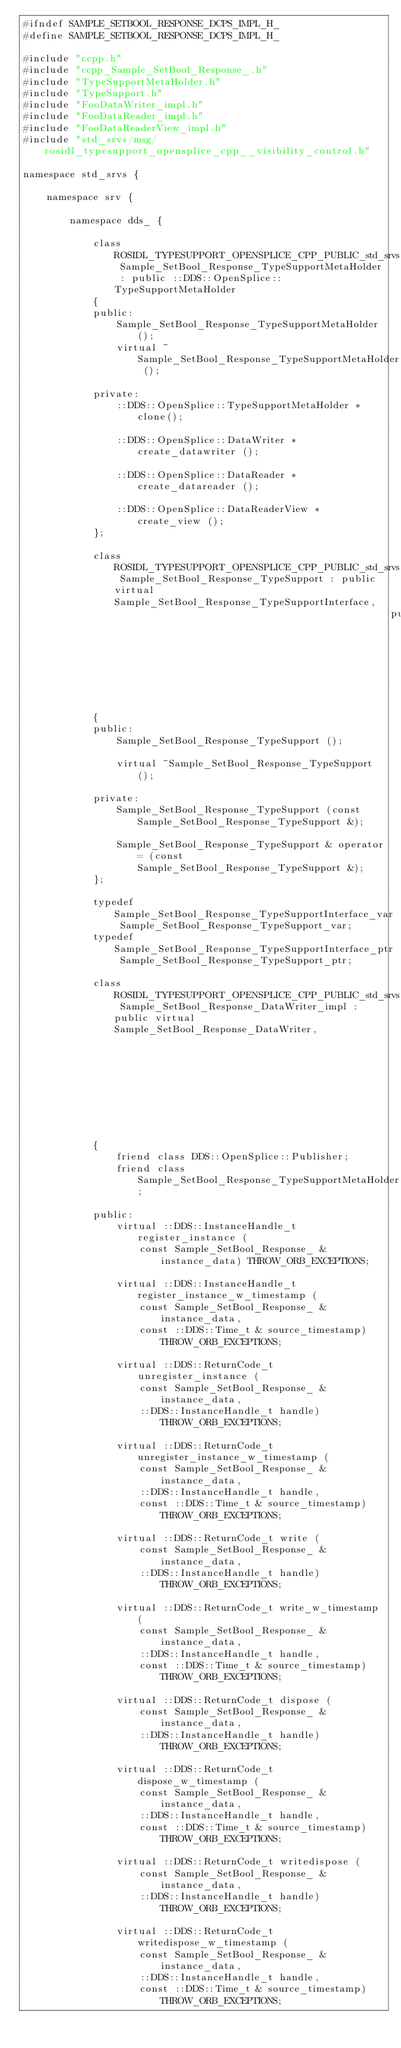Convert code to text. <code><loc_0><loc_0><loc_500><loc_500><_C_>#ifndef SAMPLE_SETBOOL_RESPONSE_DCPS_IMPL_H_
#define SAMPLE_SETBOOL_RESPONSE_DCPS_IMPL_H_

#include "ccpp.h"
#include "ccpp_Sample_SetBool_Response_.h"
#include "TypeSupportMetaHolder.h"
#include "TypeSupport.h"
#include "FooDataWriter_impl.h"
#include "FooDataReader_impl.h"
#include "FooDataReaderView_impl.h"
#include "std_srvs/msg/rosidl_typesupport_opensplice_cpp__visibility_control.h"

namespace std_srvs {

    namespace srv {

        namespace dds_ {

            class ROSIDL_TYPESUPPORT_OPENSPLICE_CPP_PUBLIC_std_srvs Sample_SetBool_Response_TypeSupportMetaHolder : public ::DDS::OpenSplice::TypeSupportMetaHolder
            {
            public:
                Sample_SetBool_Response_TypeSupportMetaHolder ();
                virtual ~Sample_SetBool_Response_TypeSupportMetaHolder ();
            
            private:
                ::DDS::OpenSplice::TypeSupportMetaHolder * clone();
            
                ::DDS::OpenSplice::DataWriter * create_datawriter ();
            
                ::DDS::OpenSplice::DataReader * create_datareader ();
            
                ::DDS::OpenSplice::DataReaderView * create_view ();
            };
            
            class ROSIDL_TYPESUPPORT_OPENSPLICE_CPP_PUBLIC_std_srvs Sample_SetBool_Response_TypeSupport : public virtual Sample_SetBool_Response_TypeSupportInterface,
                                                               public ::DDS::OpenSplice::TypeSupport
            {
            public:
                Sample_SetBool_Response_TypeSupport ();
            
                virtual ~Sample_SetBool_Response_TypeSupport ();
            
            private:
                Sample_SetBool_Response_TypeSupport (const Sample_SetBool_Response_TypeSupport &);
            
                Sample_SetBool_Response_TypeSupport & operator= (const Sample_SetBool_Response_TypeSupport &);
            };
            
            typedef Sample_SetBool_Response_TypeSupportInterface_var Sample_SetBool_Response_TypeSupport_var;
            typedef Sample_SetBool_Response_TypeSupportInterface_ptr Sample_SetBool_Response_TypeSupport_ptr;
            
            class ROSIDL_TYPESUPPORT_OPENSPLICE_CPP_PUBLIC_std_srvs Sample_SetBool_Response_DataWriter_impl : public virtual Sample_SetBool_Response_DataWriter,
                                                                   public ::DDS::OpenSplice::FooDataWriter_impl
            {
                friend class DDS::OpenSplice::Publisher;
                friend class Sample_SetBool_Response_TypeSupportMetaHolder;
            
            public:
                virtual ::DDS::InstanceHandle_t register_instance (
                    const Sample_SetBool_Response_ & instance_data) THROW_ORB_EXCEPTIONS;
            
                virtual ::DDS::InstanceHandle_t register_instance_w_timestamp (
                    const Sample_SetBool_Response_ & instance_data,
                    const ::DDS::Time_t & source_timestamp) THROW_ORB_EXCEPTIONS;
            
                virtual ::DDS::ReturnCode_t unregister_instance (
                    const Sample_SetBool_Response_ & instance_data,
                    ::DDS::InstanceHandle_t handle) THROW_ORB_EXCEPTIONS;
            
                virtual ::DDS::ReturnCode_t unregister_instance_w_timestamp (
                    const Sample_SetBool_Response_ & instance_data,
                    ::DDS::InstanceHandle_t handle,
                    const ::DDS::Time_t & source_timestamp) THROW_ORB_EXCEPTIONS;
            
                virtual ::DDS::ReturnCode_t write (
                    const Sample_SetBool_Response_ & instance_data,
                    ::DDS::InstanceHandle_t handle) THROW_ORB_EXCEPTIONS;
            
                virtual ::DDS::ReturnCode_t write_w_timestamp (
                    const Sample_SetBool_Response_ & instance_data,
                    ::DDS::InstanceHandle_t handle,
                    const ::DDS::Time_t & source_timestamp) THROW_ORB_EXCEPTIONS;
            
                virtual ::DDS::ReturnCode_t dispose (
                    const Sample_SetBool_Response_ & instance_data,
                    ::DDS::InstanceHandle_t handle) THROW_ORB_EXCEPTIONS;
            
                virtual ::DDS::ReturnCode_t dispose_w_timestamp (
                    const Sample_SetBool_Response_ & instance_data,
                    ::DDS::InstanceHandle_t handle,
                    const ::DDS::Time_t & source_timestamp) THROW_ORB_EXCEPTIONS;
            
                virtual ::DDS::ReturnCode_t writedispose (
                    const Sample_SetBool_Response_ & instance_data,
                    ::DDS::InstanceHandle_t handle) THROW_ORB_EXCEPTIONS;
            
                virtual ::DDS::ReturnCode_t writedispose_w_timestamp (
                    const Sample_SetBool_Response_ & instance_data,
                    ::DDS::InstanceHandle_t handle,
                    const ::DDS::Time_t & source_timestamp) THROW_ORB_EXCEPTIONS;
            </code> 